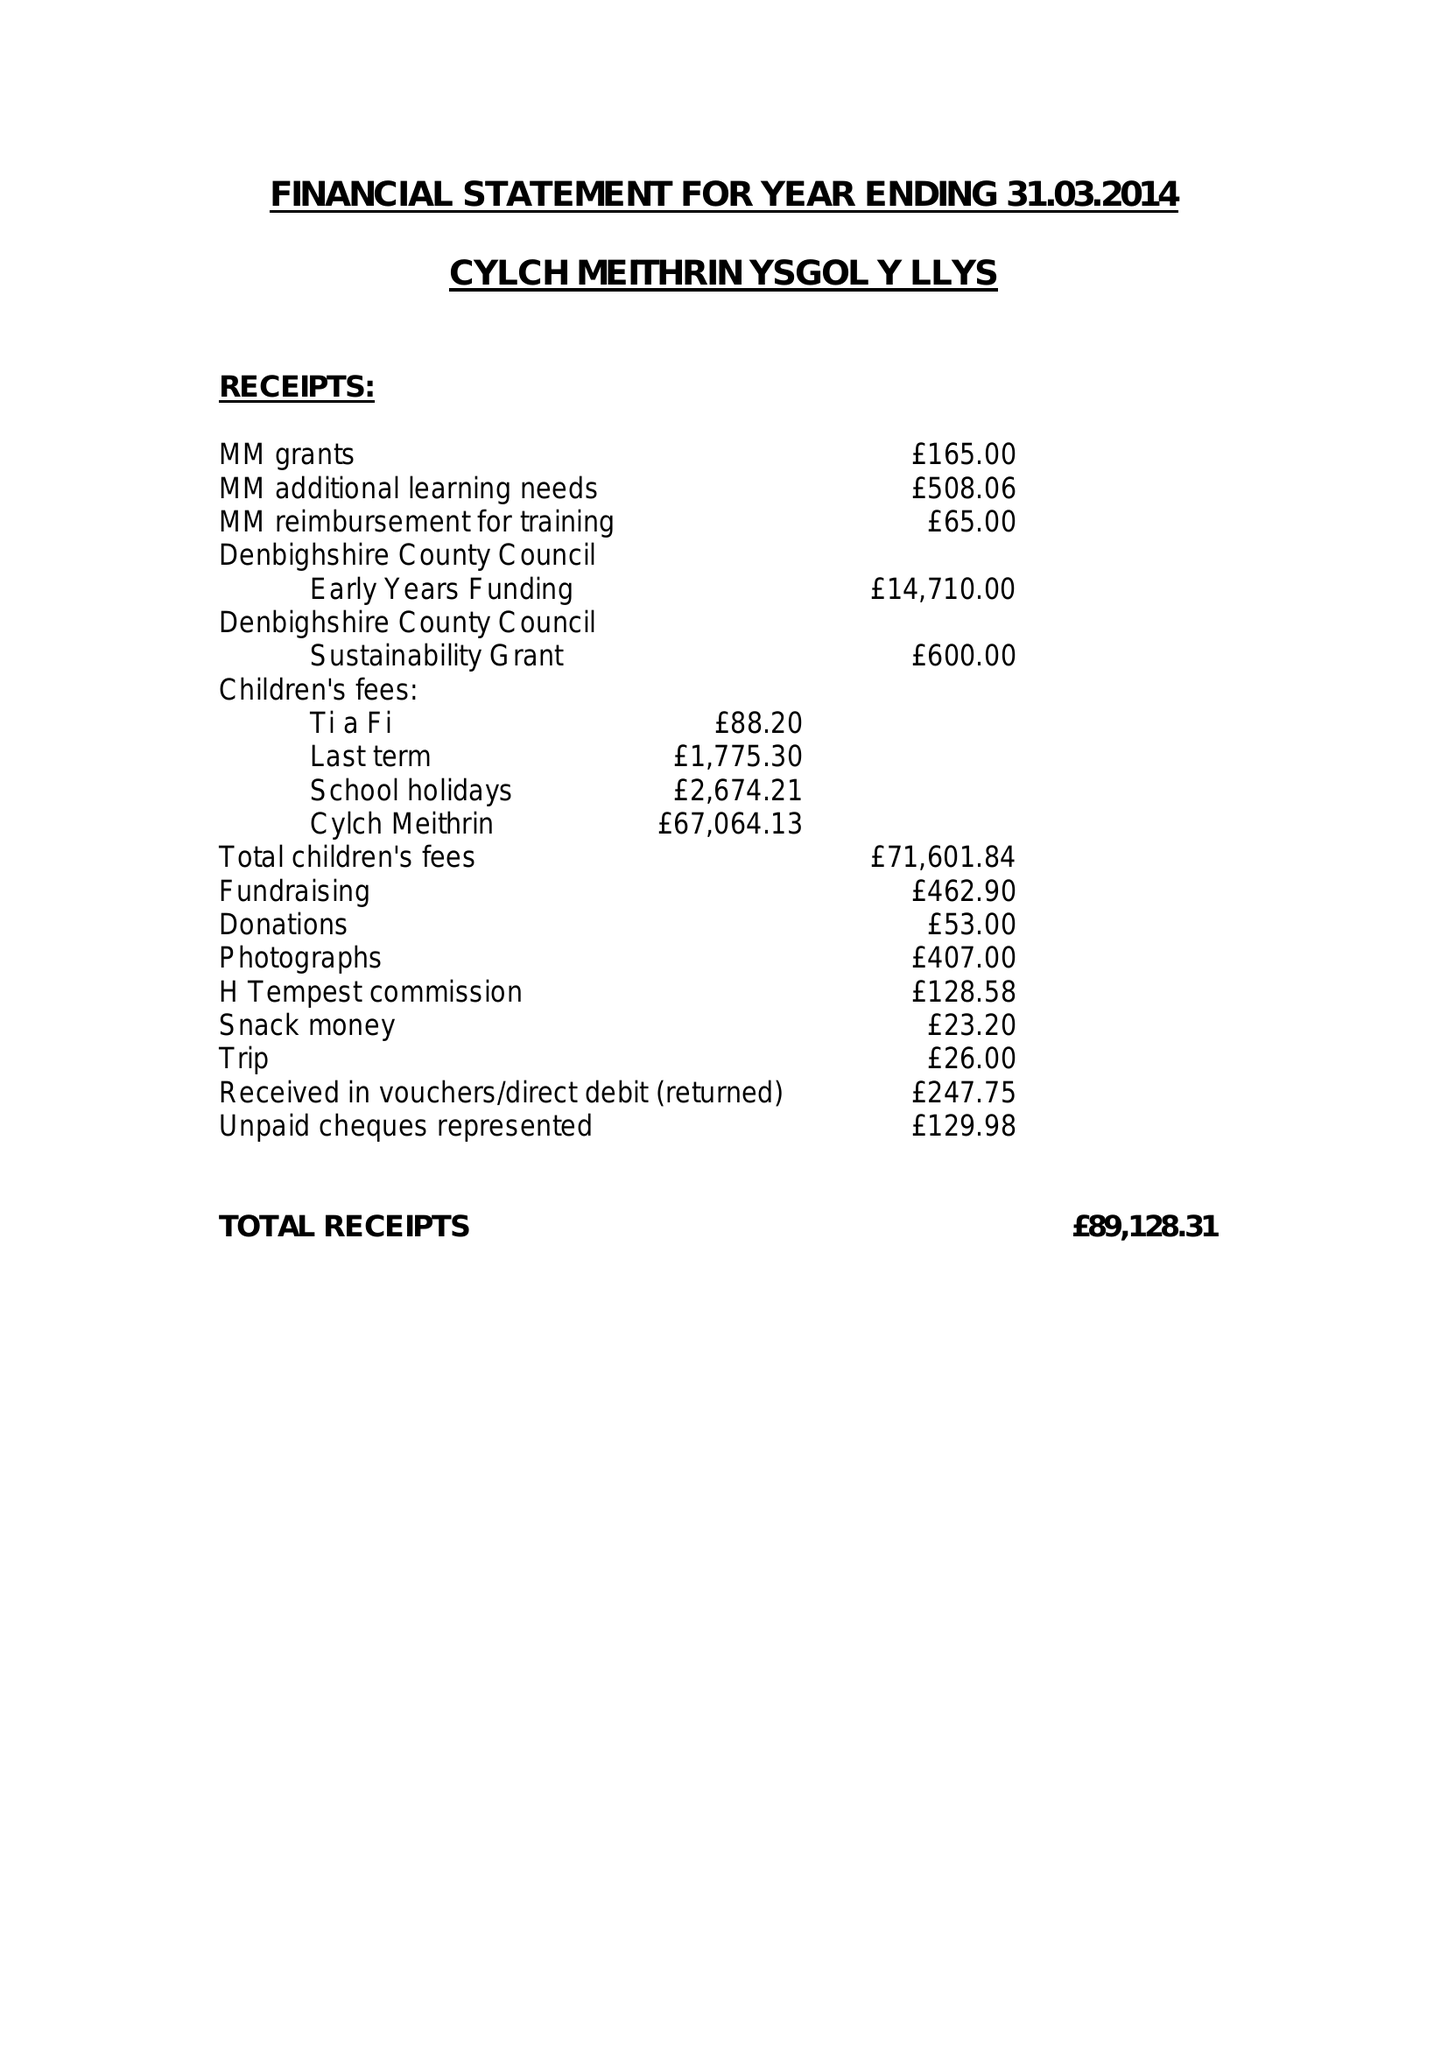What is the value for the income_annually_in_british_pounds?
Answer the question using a single word or phrase. 89128.31 